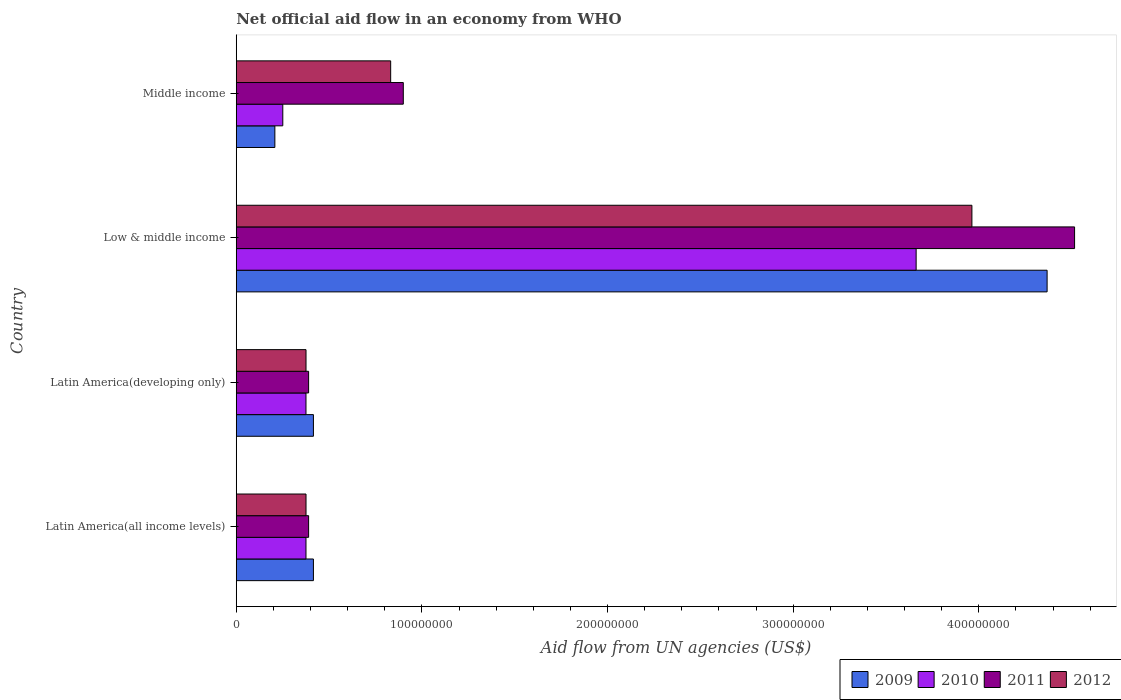How many different coloured bars are there?
Offer a terse response. 4. Are the number of bars per tick equal to the number of legend labels?
Make the answer very short. Yes. How many bars are there on the 1st tick from the bottom?
Keep it short and to the point. 4. What is the label of the 4th group of bars from the top?
Make the answer very short. Latin America(all income levels). In how many cases, is the number of bars for a given country not equal to the number of legend labels?
Your answer should be very brief. 0. What is the net official aid flow in 2009 in Latin America(developing only)?
Your response must be concise. 4.16e+07. Across all countries, what is the maximum net official aid flow in 2012?
Your answer should be very brief. 3.96e+08. Across all countries, what is the minimum net official aid flow in 2009?
Your answer should be compact. 2.08e+07. What is the total net official aid flow in 2012 in the graph?
Provide a short and direct response. 5.55e+08. What is the difference between the net official aid flow in 2010 in Latin America(developing only) and that in Low & middle income?
Ensure brevity in your answer.  -3.29e+08. What is the difference between the net official aid flow in 2011 in Latin America(all income levels) and the net official aid flow in 2012 in Middle income?
Your answer should be compact. -4.42e+07. What is the average net official aid flow in 2011 per country?
Ensure brevity in your answer.  1.55e+08. What is the difference between the net official aid flow in 2011 and net official aid flow in 2009 in Low & middle income?
Offer a very short reply. 1.48e+07. What is the ratio of the net official aid flow in 2010 in Latin America(developing only) to that in Middle income?
Offer a terse response. 1.5. Is the net official aid flow in 2009 in Latin America(all income levels) less than that in Middle income?
Offer a very short reply. No. Is the difference between the net official aid flow in 2011 in Low & middle income and Middle income greater than the difference between the net official aid flow in 2009 in Low & middle income and Middle income?
Offer a terse response. No. What is the difference between the highest and the second highest net official aid flow in 2011?
Your answer should be compact. 3.62e+08. What is the difference between the highest and the lowest net official aid flow in 2010?
Provide a succinct answer. 3.41e+08. What does the 3rd bar from the top in Middle income represents?
Offer a terse response. 2010. What does the 2nd bar from the bottom in Middle income represents?
Keep it short and to the point. 2010. Is it the case that in every country, the sum of the net official aid flow in 2010 and net official aid flow in 2011 is greater than the net official aid flow in 2009?
Ensure brevity in your answer.  Yes. How many bars are there?
Ensure brevity in your answer.  16. Are all the bars in the graph horizontal?
Keep it short and to the point. Yes. Does the graph contain grids?
Your answer should be very brief. No. How many legend labels are there?
Offer a very short reply. 4. How are the legend labels stacked?
Offer a terse response. Horizontal. What is the title of the graph?
Keep it short and to the point. Net official aid flow in an economy from WHO. Does "1965" appear as one of the legend labels in the graph?
Your answer should be compact. No. What is the label or title of the X-axis?
Make the answer very short. Aid flow from UN agencies (US$). What is the label or title of the Y-axis?
Make the answer very short. Country. What is the Aid flow from UN agencies (US$) in 2009 in Latin America(all income levels)?
Your response must be concise. 4.16e+07. What is the Aid flow from UN agencies (US$) in 2010 in Latin America(all income levels)?
Provide a succinct answer. 3.76e+07. What is the Aid flow from UN agencies (US$) of 2011 in Latin America(all income levels)?
Offer a very short reply. 3.90e+07. What is the Aid flow from UN agencies (US$) of 2012 in Latin America(all income levels)?
Provide a short and direct response. 3.76e+07. What is the Aid flow from UN agencies (US$) of 2009 in Latin America(developing only)?
Provide a short and direct response. 4.16e+07. What is the Aid flow from UN agencies (US$) in 2010 in Latin America(developing only)?
Provide a succinct answer. 3.76e+07. What is the Aid flow from UN agencies (US$) in 2011 in Latin America(developing only)?
Offer a very short reply. 3.90e+07. What is the Aid flow from UN agencies (US$) of 2012 in Latin America(developing only)?
Make the answer very short. 3.76e+07. What is the Aid flow from UN agencies (US$) in 2009 in Low & middle income?
Offer a very short reply. 4.37e+08. What is the Aid flow from UN agencies (US$) in 2010 in Low & middle income?
Provide a succinct answer. 3.66e+08. What is the Aid flow from UN agencies (US$) of 2011 in Low & middle income?
Keep it short and to the point. 4.52e+08. What is the Aid flow from UN agencies (US$) of 2012 in Low & middle income?
Keep it short and to the point. 3.96e+08. What is the Aid flow from UN agencies (US$) in 2009 in Middle income?
Offer a terse response. 2.08e+07. What is the Aid flow from UN agencies (US$) of 2010 in Middle income?
Offer a terse response. 2.51e+07. What is the Aid flow from UN agencies (US$) of 2011 in Middle income?
Keep it short and to the point. 9.00e+07. What is the Aid flow from UN agencies (US$) in 2012 in Middle income?
Your answer should be very brief. 8.32e+07. Across all countries, what is the maximum Aid flow from UN agencies (US$) in 2009?
Your answer should be very brief. 4.37e+08. Across all countries, what is the maximum Aid flow from UN agencies (US$) in 2010?
Offer a very short reply. 3.66e+08. Across all countries, what is the maximum Aid flow from UN agencies (US$) of 2011?
Your answer should be compact. 4.52e+08. Across all countries, what is the maximum Aid flow from UN agencies (US$) in 2012?
Make the answer very short. 3.96e+08. Across all countries, what is the minimum Aid flow from UN agencies (US$) of 2009?
Give a very brief answer. 2.08e+07. Across all countries, what is the minimum Aid flow from UN agencies (US$) in 2010?
Provide a short and direct response. 2.51e+07. Across all countries, what is the minimum Aid flow from UN agencies (US$) of 2011?
Ensure brevity in your answer.  3.90e+07. Across all countries, what is the minimum Aid flow from UN agencies (US$) of 2012?
Give a very brief answer. 3.76e+07. What is the total Aid flow from UN agencies (US$) in 2009 in the graph?
Ensure brevity in your answer.  5.41e+08. What is the total Aid flow from UN agencies (US$) of 2010 in the graph?
Offer a terse response. 4.66e+08. What is the total Aid flow from UN agencies (US$) in 2011 in the graph?
Provide a succinct answer. 6.20e+08. What is the total Aid flow from UN agencies (US$) in 2012 in the graph?
Offer a very short reply. 5.55e+08. What is the difference between the Aid flow from UN agencies (US$) of 2009 in Latin America(all income levels) and that in Latin America(developing only)?
Your response must be concise. 0. What is the difference between the Aid flow from UN agencies (US$) in 2011 in Latin America(all income levels) and that in Latin America(developing only)?
Make the answer very short. 0. What is the difference between the Aid flow from UN agencies (US$) in 2012 in Latin America(all income levels) and that in Latin America(developing only)?
Your answer should be compact. 0. What is the difference between the Aid flow from UN agencies (US$) of 2009 in Latin America(all income levels) and that in Low & middle income?
Your answer should be very brief. -3.95e+08. What is the difference between the Aid flow from UN agencies (US$) of 2010 in Latin America(all income levels) and that in Low & middle income?
Provide a succinct answer. -3.29e+08. What is the difference between the Aid flow from UN agencies (US$) in 2011 in Latin America(all income levels) and that in Low & middle income?
Ensure brevity in your answer.  -4.13e+08. What is the difference between the Aid flow from UN agencies (US$) of 2012 in Latin America(all income levels) and that in Low & middle income?
Provide a succinct answer. -3.59e+08. What is the difference between the Aid flow from UN agencies (US$) in 2009 in Latin America(all income levels) and that in Middle income?
Make the answer very short. 2.08e+07. What is the difference between the Aid flow from UN agencies (US$) in 2010 in Latin America(all income levels) and that in Middle income?
Keep it short and to the point. 1.25e+07. What is the difference between the Aid flow from UN agencies (US$) in 2011 in Latin America(all income levels) and that in Middle income?
Give a very brief answer. -5.10e+07. What is the difference between the Aid flow from UN agencies (US$) in 2012 in Latin America(all income levels) and that in Middle income?
Provide a succinct answer. -4.56e+07. What is the difference between the Aid flow from UN agencies (US$) in 2009 in Latin America(developing only) and that in Low & middle income?
Ensure brevity in your answer.  -3.95e+08. What is the difference between the Aid flow from UN agencies (US$) of 2010 in Latin America(developing only) and that in Low & middle income?
Give a very brief answer. -3.29e+08. What is the difference between the Aid flow from UN agencies (US$) in 2011 in Latin America(developing only) and that in Low & middle income?
Keep it short and to the point. -4.13e+08. What is the difference between the Aid flow from UN agencies (US$) in 2012 in Latin America(developing only) and that in Low & middle income?
Ensure brevity in your answer.  -3.59e+08. What is the difference between the Aid flow from UN agencies (US$) in 2009 in Latin America(developing only) and that in Middle income?
Provide a succinct answer. 2.08e+07. What is the difference between the Aid flow from UN agencies (US$) of 2010 in Latin America(developing only) and that in Middle income?
Offer a very short reply. 1.25e+07. What is the difference between the Aid flow from UN agencies (US$) in 2011 in Latin America(developing only) and that in Middle income?
Give a very brief answer. -5.10e+07. What is the difference between the Aid flow from UN agencies (US$) in 2012 in Latin America(developing only) and that in Middle income?
Give a very brief answer. -4.56e+07. What is the difference between the Aid flow from UN agencies (US$) of 2009 in Low & middle income and that in Middle income?
Provide a short and direct response. 4.16e+08. What is the difference between the Aid flow from UN agencies (US$) of 2010 in Low & middle income and that in Middle income?
Provide a short and direct response. 3.41e+08. What is the difference between the Aid flow from UN agencies (US$) in 2011 in Low & middle income and that in Middle income?
Your answer should be compact. 3.62e+08. What is the difference between the Aid flow from UN agencies (US$) in 2012 in Low & middle income and that in Middle income?
Give a very brief answer. 3.13e+08. What is the difference between the Aid flow from UN agencies (US$) of 2009 in Latin America(all income levels) and the Aid flow from UN agencies (US$) of 2010 in Latin America(developing only)?
Your answer should be compact. 4.01e+06. What is the difference between the Aid flow from UN agencies (US$) of 2009 in Latin America(all income levels) and the Aid flow from UN agencies (US$) of 2011 in Latin America(developing only)?
Your answer should be compact. 2.59e+06. What is the difference between the Aid flow from UN agencies (US$) of 2009 in Latin America(all income levels) and the Aid flow from UN agencies (US$) of 2012 in Latin America(developing only)?
Offer a very short reply. 3.99e+06. What is the difference between the Aid flow from UN agencies (US$) in 2010 in Latin America(all income levels) and the Aid flow from UN agencies (US$) in 2011 in Latin America(developing only)?
Offer a terse response. -1.42e+06. What is the difference between the Aid flow from UN agencies (US$) in 2010 in Latin America(all income levels) and the Aid flow from UN agencies (US$) in 2012 in Latin America(developing only)?
Offer a very short reply. -2.00e+04. What is the difference between the Aid flow from UN agencies (US$) in 2011 in Latin America(all income levels) and the Aid flow from UN agencies (US$) in 2012 in Latin America(developing only)?
Your answer should be very brief. 1.40e+06. What is the difference between the Aid flow from UN agencies (US$) of 2009 in Latin America(all income levels) and the Aid flow from UN agencies (US$) of 2010 in Low & middle income?
Offer a terse response. -3.25e+08. What is the difference between the Aid flow from UN agencies (US$) of 2009 in Latin America(all income levels) and the Aid flow from UN agencies (US$) of 2011 in Low & middle income?
Provide a short and direct response. -4.10e+08. What is the difference between the Aid flow from UN agencies (US$) in 2009 in Latin America(all income levels) and the Aid flow from UN agencies (US$) in 2012 in Low & middle income?
Your answer should be very brief. -3.55e+08. What is the difference between the Aid flow from UN agencies (US$) in 2010 in Latin America(all income levels) and the Aid flow from UN agencies (US$) in 2011 in Low & middle income?
Ensure brevity in your answer.  -4.14e+08. What is the difference between the Aid flow from UN agencies (US$) of 2010 in Latin America(all income levels) and the Aid flow from UN agencies (US$) of 2012 in Low & middle income?
Make the answer very short. -3.59e+08. What is the difference between the Aid flow from UN agencies (US$) of 2011 in Latin America(all income levels) and the Aid flow from UN agencies (US$) of 2012 in Low & middle income?
Ensure brevity in your answer.  -3.57e+08. What is the difference between the Aid flow from UN agencies (US$) in 2009 in Latin America(all income levels) and the Aid flow from UN agencies (US$) in 2010 in Middle income?
Your answer should be very brief. 1.65e+07. What is the difference between the Aid flow from UN agencies (US$) in 2009 in Latin America(all income levels) and the Aid flow from UN agencies (US$) in 2011 in Middle income?
Your response must be concise. -4.84e+07. What is the difference between the Aid flow from UN agencies (US$) in 2009 in Latin America(all income levels) and the Aid flow from UN agencies (US$) in 2012 in Middle income?
Your answer should be very brief. -4.16e+07. What is the difference between the Aid flow from UN agencies (US$) of 2010 in Latin America(all income levels) and the Aid flow from UN agencies (US$) of 2011 in Middle income?
Offer a very short reply. -5.24e+07. What is the difference between the Aid flow from UN agencies (US$) in 2010 in Latin America(all income levels) and the Aid flow from UN agencies (US$) in 2012 in Middle income?
Offer a very short reply. -4.56e+07. What is the difference between the Aid flow from UN agencies (US$) of 2011 in Latin America(all income levels) and the Aid flow from UN agencies (US$) of 2012 in Middle income?
Keep it short and to the point. -4.42e+07. What is the difference between the Aid flow from UN agencies (US$) in 2009 in Latin America(developing only) and the Aid flow from UN agencies (US$) in 2010 in Low & middle income?
Offer a terse response. -3.25e+08. What is the difference between the Aid flow from UN agencies (US$) of 2009 in Latin America(developing only) and the Aid flow from UN agencies (US$) of 2011 in Low & middle income?
Your answer should be compact. -4.10e+08. What is the difference between the Aid flow from UN agencies (US$) in 2009 in Latin America(developing only) and the Aid flow from UN agencies (US$) in 2012 in Low & middle income?
Ensure brevity in your answer.  -3.55e+08. What is the difference between the Aid flow from UN agencies (US$) of 2010 in Latin America(developing only) and the Aid flow from UN agencies (US$) of 2011 in Low & middle income?
Your response must be concise. -4.14e+08. What is the difference between the Aid flow from UN agencies (US$) of 2010 in Latin America(developing only) and the Aid flow from UN agencies (US$) of 2012 in Low & middle income?
Ensure brevity in your answer.  -3.59e+08. What is the difference between the Aid flow from UN agencies (US$) of 2011 in Latin America(developing only) and the Aid flow from UN agencies (US$) of 2012 in Low & middle income?
Your answer should be very brief. -3.57e+08. What is the difference between the Aid flow from UN agencies (US$) in 2009 in Latin America(developing only) and the Aid flow from UN agencies (US$) in 2010 in Middle income?
Your answer should be very brief. 1.65e+07. What is the difference between the Aid flow from UN agencies (US$) of 2009 in Latin America(developing only) and the Aid flow from UN agencies (US$) of 2011 in Middle income?
Your answer should be compact. -4.84e+07. What is the difference between the Aid flow from UN agencies (US$) in 2009 in Latin America(developing only) and the Aid flow from UN agencies (US$) in 2012 in Middle income?
Your answer should be very brief. -4.16e+07. What is the difference between the Aid flow from UN agencies (US$) in 2010 in Latin America(developing only) and the Aid flow from UN agencies (US$) in 2011 in Middle income?
Keep it short and to the point. -5.24e+07. What is the difference between the Aid flow from UN agencies (US$) in 2010 in Latin America(developing only) and the Aid flow from UN agencies (US$) in 2012 in Middle income?
Your answer should be very brief. -4.56e+07. What is the difference between the Aid flow from UN agencies (US$) in 2011 in Latin America(developing only) and the Aid flow from UN agencies (US$) in 2012 in Middle income?
Your response must be concise. -4.42e+07. What is the difference between the Aid flow from UN agencies (US$) of 2009 in Low & middle income and the Aid flow from UN agencies (US$) of 2010 in Middle income?
Provide a short and direct response. 4.12e+08. What is the difference between the Aid flow from UN agencies (US$) in 2009 in Low & middle income and the Aid flow from UN agencies (US$) in 2011 in Middle income?
Offer a very short reply. 3.47e+08. What is the difference between the Aid flow from UN agencies (US$) in 2009 in Low & middle income and the Aid flow from UN agencies (US$) in 2012 in Middle income?
Offer a terse response. 3.54e+08. What is the difference between the Aid flow from UN agencies (US$) of 2010 in Low & middle income and the Aid flow from UN agencies (US$) of 2011 in Middle income?
Provide a short and direct response. 2.76e+08. What is the difference between the Aid flow from UN agencies (US$) of 2010 in Low & middle income and the Aid flow from UN agencies (US$) of 2012 in Middle income?
Offer a terse response. 2.83e+08. What is the difference between the Aid flow from UN agencies (US$) in 2011 in Low & middle income and the Aid flow from UN agencies (US$) in 2012 in Middle income?
Your answer should be compact. 3.68e+08. What is the average Aid flow from UN agencies (US$) of 2009 per country?
Provide a short and direct response. 1.35e+08. What is the average Aid flow from UN agencies (US$) of 2010 per country?
Your answer should be very brief. 1.17e+08. What is the average Aid flow from UN agencies (US$) of 2011 per country?
Your answer should be very brief. 1.55e+08. What is the average Aid flow from UN agencies (US$) in 2012 per country?
Keep it short and to the point. 1.39e+08. What is the difference between the Aid flow from UN agencies (US$) in 2009 and Aid flow from UN agencies (US$) in 2010 in Latin America(all income levels)?
Give a very brief answer. 4.01e+06. What is the difference between the Aid flow from UN agencies (US$) of 2009 and Aid flow from UN agencies (US$) of 2011 in Latin America(all income levels)?
Make the answer very short. 2.59e+06. What is the difference between the Aid flow from UN agencies (US$) in 2009 and Aid flow from UN agencies (US$) in 2012 in Latin America(all income levels)?
Your answer should be compact. 3.99e+06. What is the difference between the Aid flow from UN agencies (US$) in 2010 and Aid flow from UN agencies (US$) in 2011 in Latin America(all income levels)?
Provide a short and direct response. -1.42e+06. What is the difference between the Aid flow from UN agencies (US$) in 2010 and Aid flow from UN agencies (US$) in 2012 in Latin America(all income levels)?
Your answer should be very brief. -2.00e+04. What is the difference between the Aid flow from UN agencies (US$) in 2011 and Aid flow from UN agencies (US$) in 2012 in Latin America(all income levels)?
Your answer should be compact. 1.40e+06. What is the difference between the Aid flow from UN agencies (US$) of 2009 and Aid flow from UN agencies (US$) of 2010 in Latin America(developing only)?
Make the answer very short. 4.01e+06. What is the difference between the Aid flow from UN agencies (US$) of 2009 and Aid flow from UN agencies (US$) of 2011 in Latin America(developing only)?
Give a very brief answer. 2.59e+06. What is the difference between the Aid flow from UN agencies (US$) of 2009 and Aid flow from UN agencies (US$) of 2012 in Latin America(developing only)?
Offer a very short reply. 3.99e+06. What is the difference between the Aid flow from UN agencies (US$) of 2010 and Aid flow from UN agencies (US$) of 2011 in Latin America(developing only)?
Offer a terse response. -1.42e+06. What is the difference between the Aid flow from UN agencies (US$) in 2010 and Aid flow from UN agencies (US$) in 2012 in Latin America(developing only)?
Keep it short and to the point. -2.00e+04. What is the difference between the Aid flow from UN agencies (US$) in 2011 and Aid flow from UN agencies (US$) in 2012 in Latin America(developing only)?
Offer a very short reply. 1.40e+06. What is the difference between the Aid flow from UN agencies (US$) of 2009 and Aid flow from UN agencies (US$) of 2010 in Low & middle income?
Your answer should be compact. 7.06e+07. What is the difference between the Aid flow from UN agencies (US$) in 2009 and Aid flow from UN agencies (US$) in 2011 in Low & middle income?
Your answer should be compact. -1.48e+07. What is the difference between the Aid flow from UN agencies (US$) in 2009 and Aid flow from UN agencies (US$) in 2012 in Low & middle income?
Your answer should be very brief. 4.05e+07. What is the difference between the Aid flow from UN agencies (US$) of 2010 and Aid flow from UN agencies (US$) of 2011 in Low & middle income?
Make the answer very short. -8.54e+07. What is the difference between the Aid flow from UN agencies (US$) of 2010 and Aid flow from UN agencies (US$) of 2012 in Low & middle income?
Your response must be concise. -3.00e+07. What is the difference between the Aid flow from UN agencies (US$) of 2011 and Aid flow from UN agencies (US$) of 2012 in Low & middle income?
Ensure brevity in your answer.  5.53e+07. What is the difference between the Aid flow from UN agencies (US$) in 2009 and Aid flow from UN agencies (US$) in 2010 in Middle income?
Provide a succinct answer. -4.27e+06. What is the difference between the Aid flow from UN agencies (US$) of 2009 and Aid flow from UN agencies (US$) of 2011 in Middle income?
Your answer should be very brief. -6.92e+07. What is the difference between the Aid flow from UN agencies (US$) of 2009 and Aid flow from UN agencies (US$) of 2012 in Middle income?
Keep it short and to the point. -6.24e+07. What is the difference between the Aid flow from UN agencies (US$) of 2010 and Aid flow from UN agencies (US$) of 2011 in Middle income?
Make the answer very short. -6.49e+07. What is the difference between the Aid flow from UN agencies (US$) of 2010 and Aid flow from UN agencies (US$) of 2012 in Middle income?
Your answer should be compact. -5.81e+07. What is the difference between the Aid flow from UN agencies (US$) of 2011 and Aid flow from UN agencies (US$) of 2012 in Middle income?
Make the answer very short. 6.80e+06. What is the ratio of the Aid flow from UN agencies (US$) in 2012 in Latin America(all income levels) to that in Latin America(developing only)?
Provide a short and direct response. 1. What is the ratio of the Aid flow from UN agencies (US$) in 2009 in Latin America(all income levels) to that in Low & middle income?
Provide a short and direct response. 0.1. What is the ratio of the Aid flow from UN agencies (US$) in 2010 in Latin America(all income levels) to that in Low & middle income?
Offer a terse response. 0.1. What is the ratio of the Aid flow from UN agencies (US$) of 2011 in Latin America(all income levels) to that in Low & middle income?
Ensure brevity in your answer.  0.09. What is the ratio of the Aid flow from UN agencies (US$) of 2012 in Latin America(all income levels) to that in Low & middle income?
Provide a succinct answer. 0.09. What is the ratio of the Aid flow from UN agencies (US$) of 2009 in Latin America(all income levels) to that in Middle income?
Your answer should be very brief. 2. What is the ratio of the Aid flow from UN agencies (US$) of 2010 in Latin America(all income levels) to that in Middle income?
Provide a succinct answer. 1.5. What is the ratio of the Aid flow from UN agencies (US$) of 2011 in Latin America(all income levels) to that in Middle income?
Your answer should be compact. 0.43. What is the ratio of the Aid flow from UN agencies (US$) in 2012 in Latin America(all income levels) to that in Middle income?
Your answer should be very brief. 0.45. What is the ratio of the Aid flow from UN agencies (US$) of 2009 in Latin America(developing only) to that in Low & middle income?
Give a very brief answer. 0.1. What is the ratio of the Aid flow from UN agencies (US$) of 2010 in Latin America(developing only) to that in Low & middle income?
Provide a short and direct response. 0.1. What is the ratio of the Aid flow from UN agencies (US$) in 2011 in Latin America(developing only) to that in Low & middle income?
Provide a succinct answer. 0.09. What is the ratio of the Aid flow from UN agencies (US$) of 2012 in Latin America(developing only) to that in Low & middle income?
Your response must be concise. 0.09. What is the ratio of the Aid flow from UN agencies (US$) in 2009 in Latin America(developing only) to that in Middle income?
Make the answer very short. 2. What is the ratio of the Aid flow from UN agencies (US$) of 2010 in Latin America(developing only) to that in Middle income?
Ensure brevity in your answer.  1.5. What is the ratio of the Aid flow from UN agencies (US$) of 2011 in Latin America(developing only) to that in Middle income?
Keep it short and to the point. 0.43. What is the ratio of the Aid flow from UN agencies (US$) in 2012 in Latin America(developing only) to that in Middle income?
Your answer should be very brief. 0.45. What is the ratio of the Aid flow from UN agencies (US$) of 2009 in Low & middle income to that in Middle income?
Your answer should be compact. 21. What is the ratio of the Aid flow from UN agencies (US$) of 2010 in Low & middle income to that in Middle income?
Give a very brief answer. 14.61. What is the ratio of the Aid flow from UN agencies (US$) in 2011 in Low & middle income to that in Middle income?
Offer a very short reply. 5.02. What is the ratio of the Aid flow from UN agencies (US$) of 2012 in Low & middle income to that in Middle income?
Your answer should be compact. 4.76. What is the difference between the highest and the second highest Aid flow from UN agencies (US$) of 2009?
Provide a short and direct response. 3.95e+08. What is the difference between the highest and the second highest Aid flow from UN agencies (US$) of 2010?
Your response must be concise. 3.29e+08. What is the difference between the highest and the second highest Aid flow from UN agencies (US$) in 2011?
Your answer should be very brief. 3.62e+08. What is the difference between the highest and the second highest Aid flow from UN agencies (US$) in 2012?
Ensure brevity in your answer.  3.13e+08. What is the difference between the highest and the lowest Aid flow from UN agencies (US$) in 2009?
Provide a succinct answer. 4.16e+08. What is the difference between the highest and the lowest Aid flow from UN agencies (US$) in 2010?
Provide a succinct answer. 3.41e+08. What is the difference between the highest and the lowest Aid flow from UN agencies (US$) of 2011?
Provide a succinct answer. 4.13e+08. What is the difference between the highest and the lowest Aid flow from UN agencies (US$) of 2012?
Provide a short and direct response. 3.59e+08. 